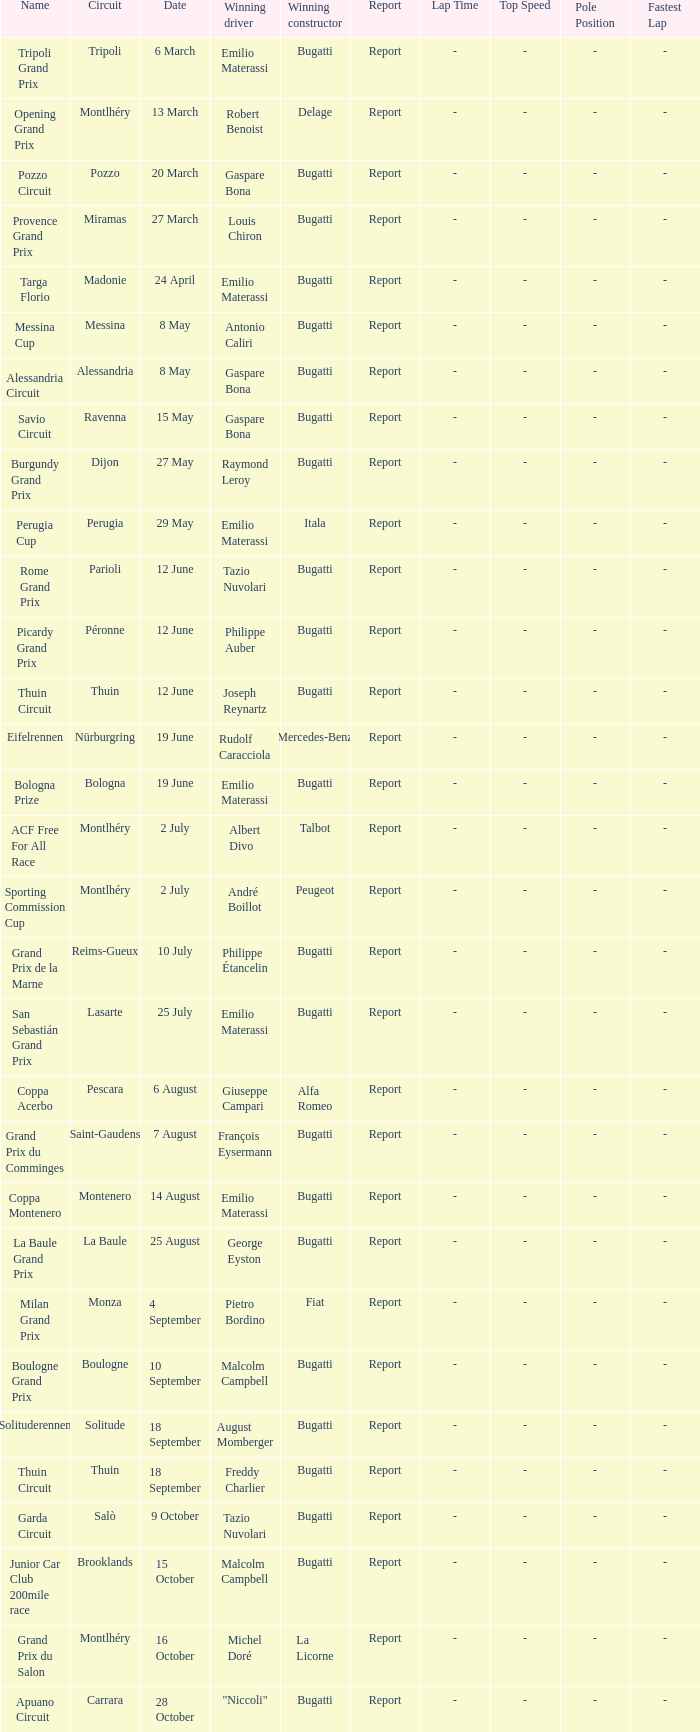Who was the winning constructor of the Grand Prix Du Salon ? La Licorne. 